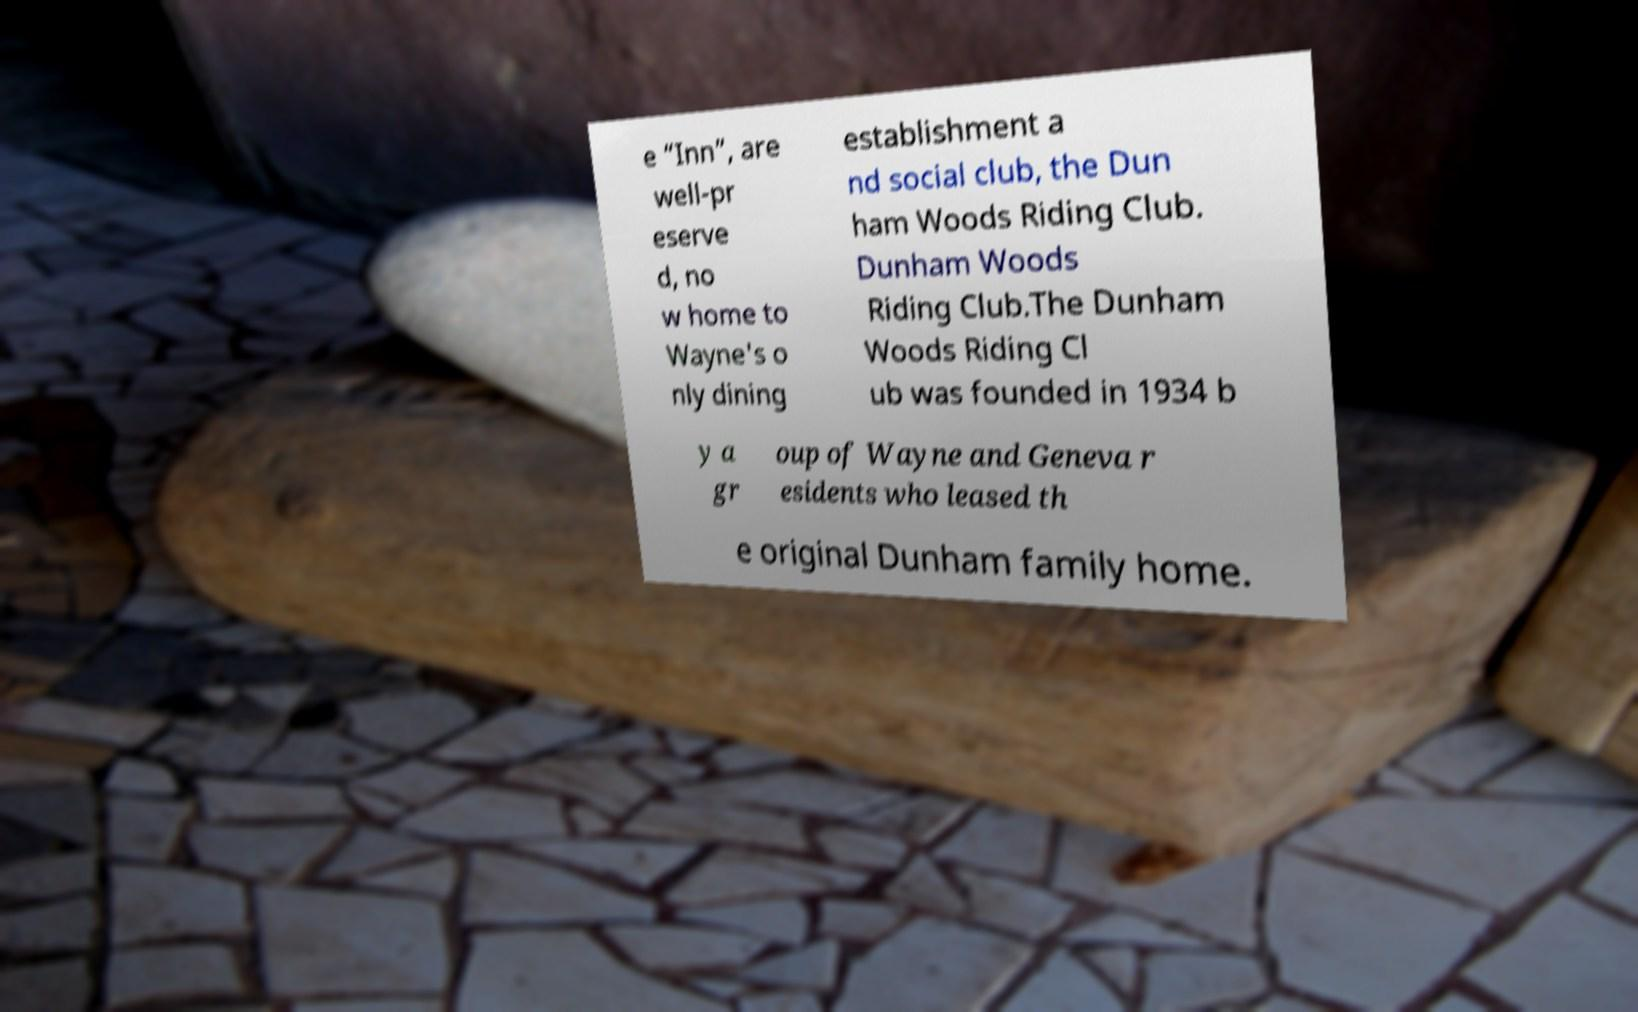I need the written content from this picture converted into text. Can you do that? e “Inn”, are well-pr eserve d, no w home to Wayne's o nly dining establishment a nd social club, the Dun ham Woods Riding Club. Dunham Woods Riding Club.The Dunham Woods Riding Cl ub was founded in 1934 b y a gr oup of Wayne and Geneva r esidents who leased th e original Dunham family home. 